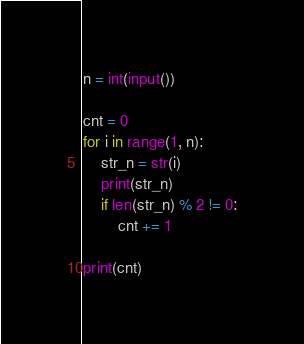<code> <loc_0><loc_0><loc_500><loc_500><_Python_>n = int(input())

cnt = 0
for i in range(1, n):
    str_n = str(i)
    print(str_n)
    if len(str_n) % 2 != 0:
        cnt += 1
        
print(cnt)</code> 